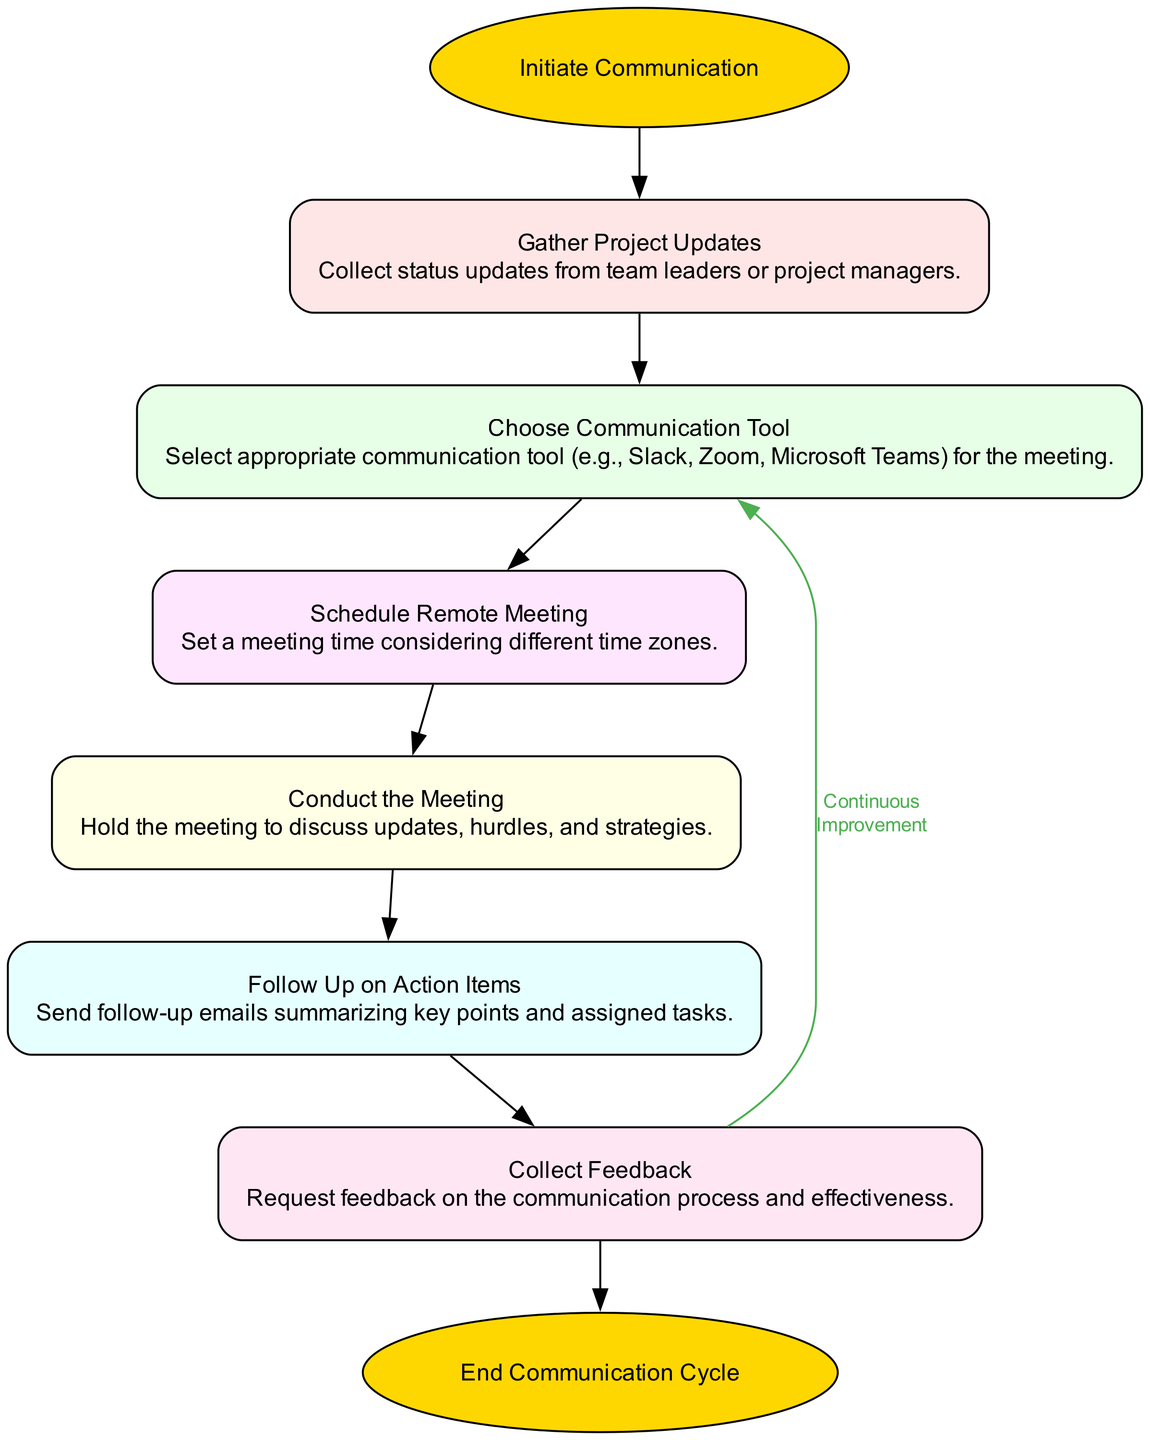What is the first step in the communication workflow? The workflow begins with the first step labeled "Initiate Communication" which indicates the starting point of the communication process with remote teams.
Answer: Initiate Communication How many main steps are in the workflow? By counting the main steps present in the diagram, there are a total of 8 steps from initiation to conclusion.
Answer: 8 Which tool is suggested for communication? The workflow allows for selection from various tools as indicated in the node "Choose Communication Tool," such as Slack, Zoom, or Microsoft Teams.
Answer: Slack, Zoom, Microsoft Teams What action follows conducting the meeting? The next action after conducting the meeting, according to the flowchart, is to "Follow Up on Action Items," indicating that action items need to be addressed post-discussion.
Answer: Follow Up on Action Items What type of feedback is collected? The diagram specifies that "Collect Feedback" is the node focused on requesting feedback regarding the communication process and its effectiveness.
Answer: Effectiveness How does the feedback loop function? The feedback loop is marked as a continuous improvement process that links back to the "Choose Communication Tool" step, indicating that feedback affects tool selection.
Answer: Continuous Improvement What color is used for the 'End Communication Cycle' node? The 'End Communication Cycle' node is yellow, shown by the yellow color applied to the elliptical shape marking the end of the workflow.
Answer: Yellow What happens after gathering project updates? Following the "Gather Project Updates" step, the next step in the workflow is to "Choose Communication Tool," signifying the progression towards scheduling and facilitating communication.
Answer: Choose Communication Tool Which part of the diagram signifies the conclusion of the process? The diagram concludes with the step labeled "End Communication Cycle," which signifies the final part of the communication workflow.
Answer: End Communication Cycle 